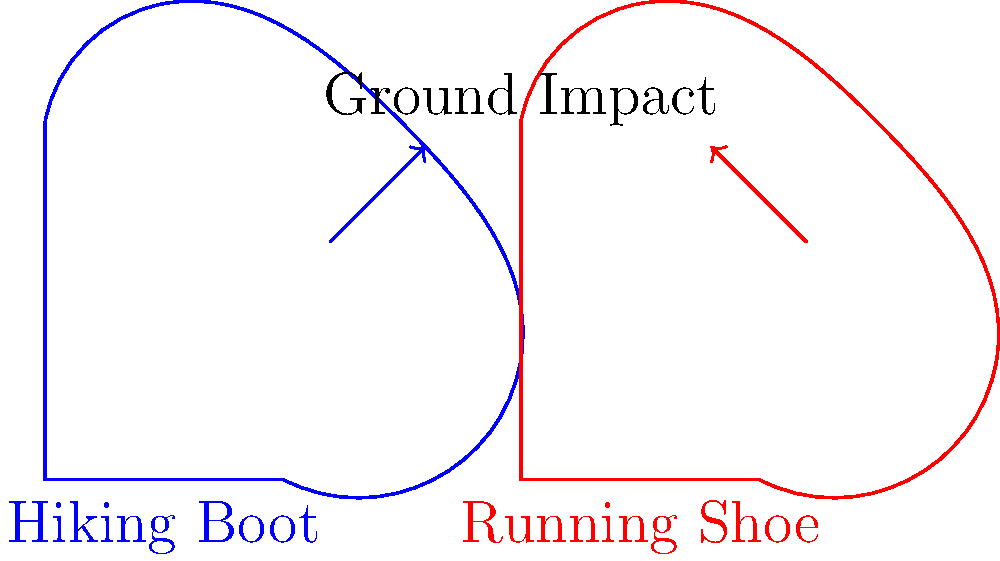During nature walks in the national park, visitors often inquire about the best footwear for their hikes. Based on the diagram, which type of shoe is likely to provide better shock absorption and reduce the risk of foot fatigue during long walks on uneven terrain? To answer this question, we need to analyze the biomechanical implications of each shoe type:

1. Hiking Boot (left):
   - The arrow points upward and outward, indicating a more distributed force.
   - This suggests that the impact is spread over a larger area of the foot.
   - Hiking boots typically have:
     a) Thicker, more rigid soles
     b) Better ankle support
     c) More robust construction

2. Running Shoe (right):
   - The arrow points upward and inward, indicating a more concentrated force.
   - This suggests that the impact is focused on a smaller area of the foot.
   - Running shoes typically have:
     a) Thinner, more flexible soles
     b) Less ankle support
     c) Lighter construction

3. Biomechanical considerations for long walks on uneven terrain:
   - Shock absorption: Hiking boots distribute the impact force over a larger area, reducing peak pressures on any single point of the foot.
   - Stability: The rigid construction and ankle support of hiking boots provide better stability on uneven surfaces.
   - Fatigue reduction: By distributing forces more evenly, hiking boots can help reduce localized fatigue in the feet.

4. Conclusion:
   While running shoes are excellent for even surfaces and short distances, the biomechanical properties of hiking boots make them more suitable for long walks on uneven terrain typically found in national parks.
Answer: Hiking boots 